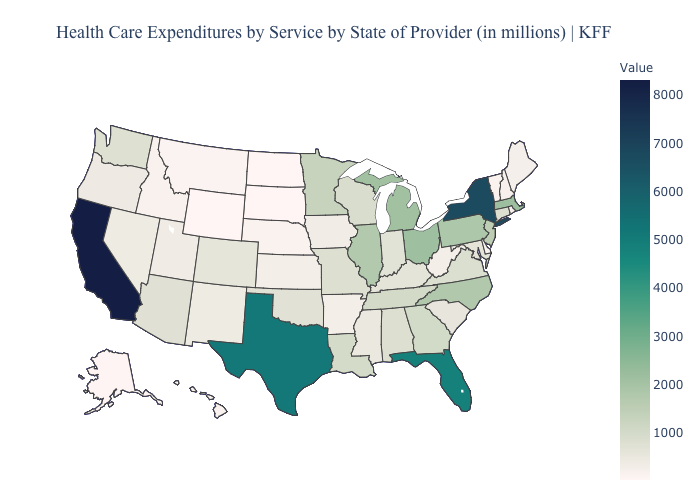Among the states that border New Mexico , which have the highest value?
Write a very short answer. Texas. Does Minnesota have the lowest value in the USA?
Concise answer only. No. Does New Hampshire have a higher value than California?
Answer briefly. No. Does South Carolina have a lower value than Florida?
Quick response, please. Yes. 